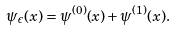Convert formula to latex. <formula><loc_0><loc_0><loc_500><loc_500>\psi _ { \epsilon } ( x ) = \psi ^ { ( 0 ) } ( x ) + \psi ^ { ( 1 ) } ( x ) .</formula> 